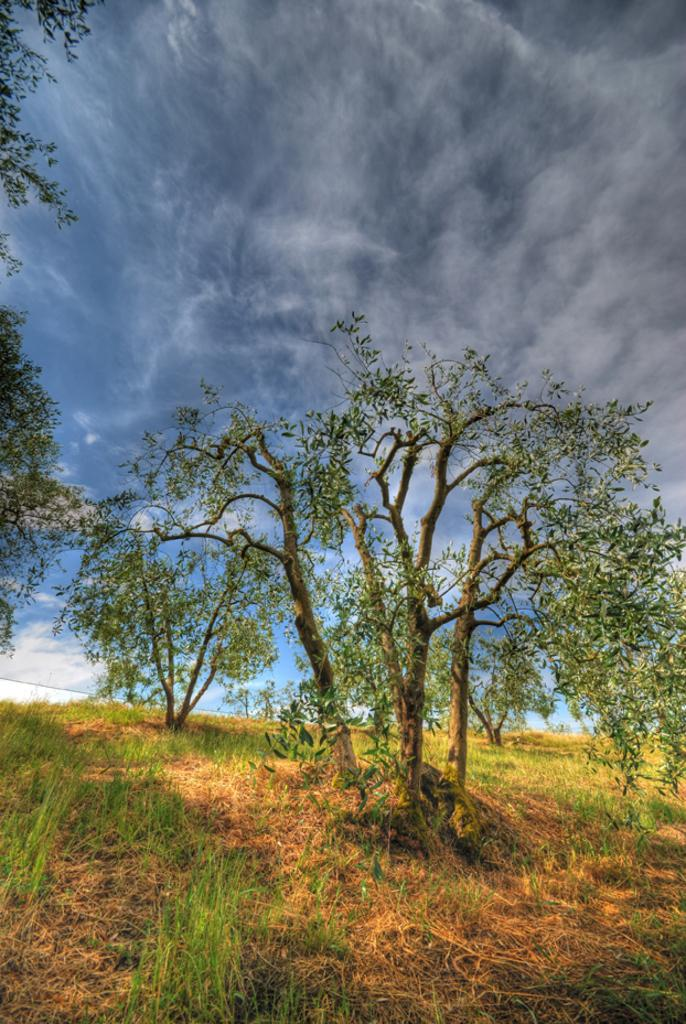What type of vegetation can be seen in the image? There are trees in the image. What is covering the ground in the image? There is grass on the ground in the image. What color is the sky in the background of the image? The sky is blue in the background of the image. Are there any weather elements visible in the sky? Yes, there are clouds in the sky in the background. How much friction is present between the potato and the ground in the image? There is no potato present in the image, so it is not possible to determine the amount of friction between a potato and the ground. 